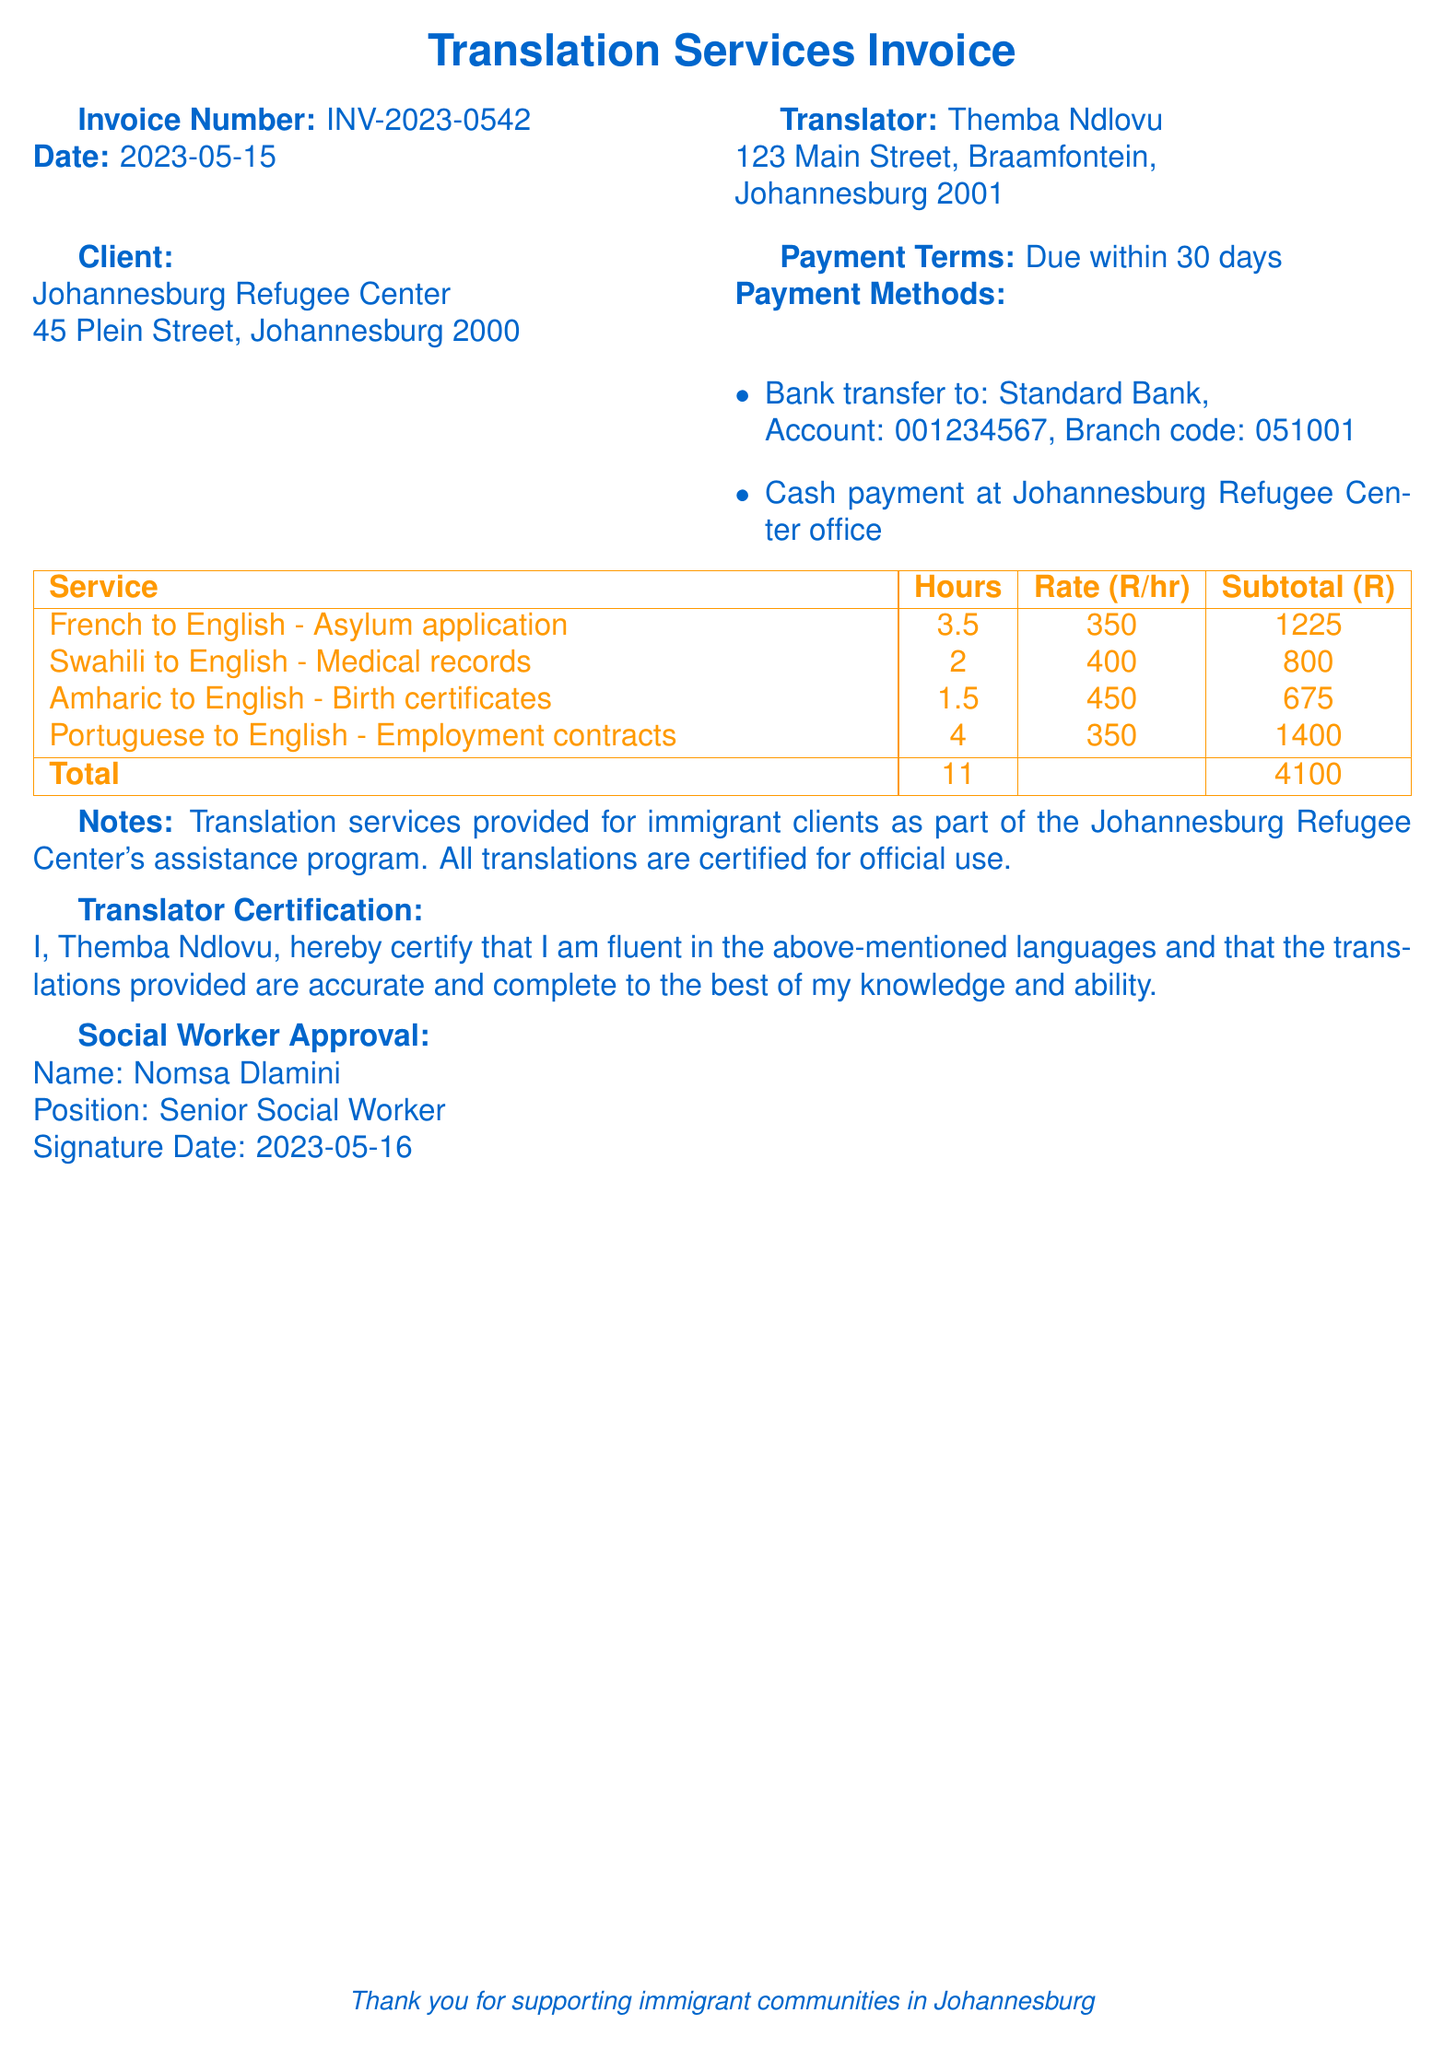What is the invoice number? The invoice number is clearly stated at the beginning of the document, which is INV-2023-0542.
Answer: INV-2023-0542 Who is the translator? The document lists the translator's name, which is Themba Ndlovu.
Answer: Themba Ndlovu What is the total amount for the services provided? The total amount is at the bottom of the services section of the document, which sums up to R4100.
Answer: R4100 How many hours were worked in total? The total hours worked is specified in the services summary, which is 11.
Answer: 11 What payment methods are accepted? The document lists the methods for payment which includes bank transfer and cash payment options.
Answer: Bank transfer, Cash payment Which language pair had the highest rate per hour? By comparing the rates per hour for each service listed, the highest rate is found for Swahili to English.
Answer: Swahili to English What is the document type for the translation of birth certificates? The document specifies this as Birth certificates under the Amharic to English service.
Answer: Birth certificates What is the date of the invoice? The date of the invoice is mentioned at the top of the document, which is 2023-05-15.
Answer: 2023-05-15 Who approved the translation services? The social worker who approved the services is named Nomsa Dlamini, as stated in the document.
Answer: Nomsa Dlamini 